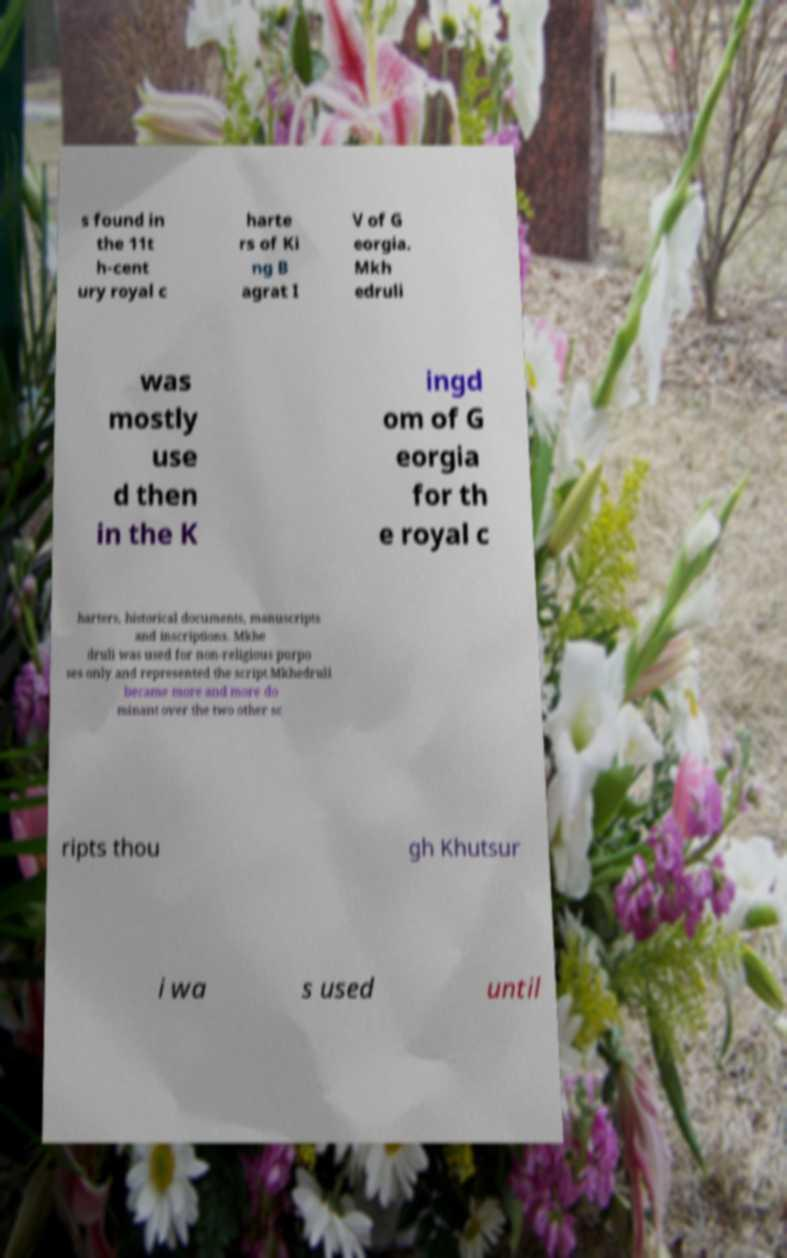Could you extract and type out the text from this image? s found in the 11t h-cent ury royal c harte rs of Ki ng B agrat I V of G eorgia. Mkh edruli was mostly use d then in the K ingd om of G eorgia for th e royal c harters, historical documents, manuscripts and inscriptions. Mkhe druli was used for non-religious purpo ses only and represented the script.Mkhedruli became more and more do minant over the two other sc ripts thou gh Khutsur i wa s used until 